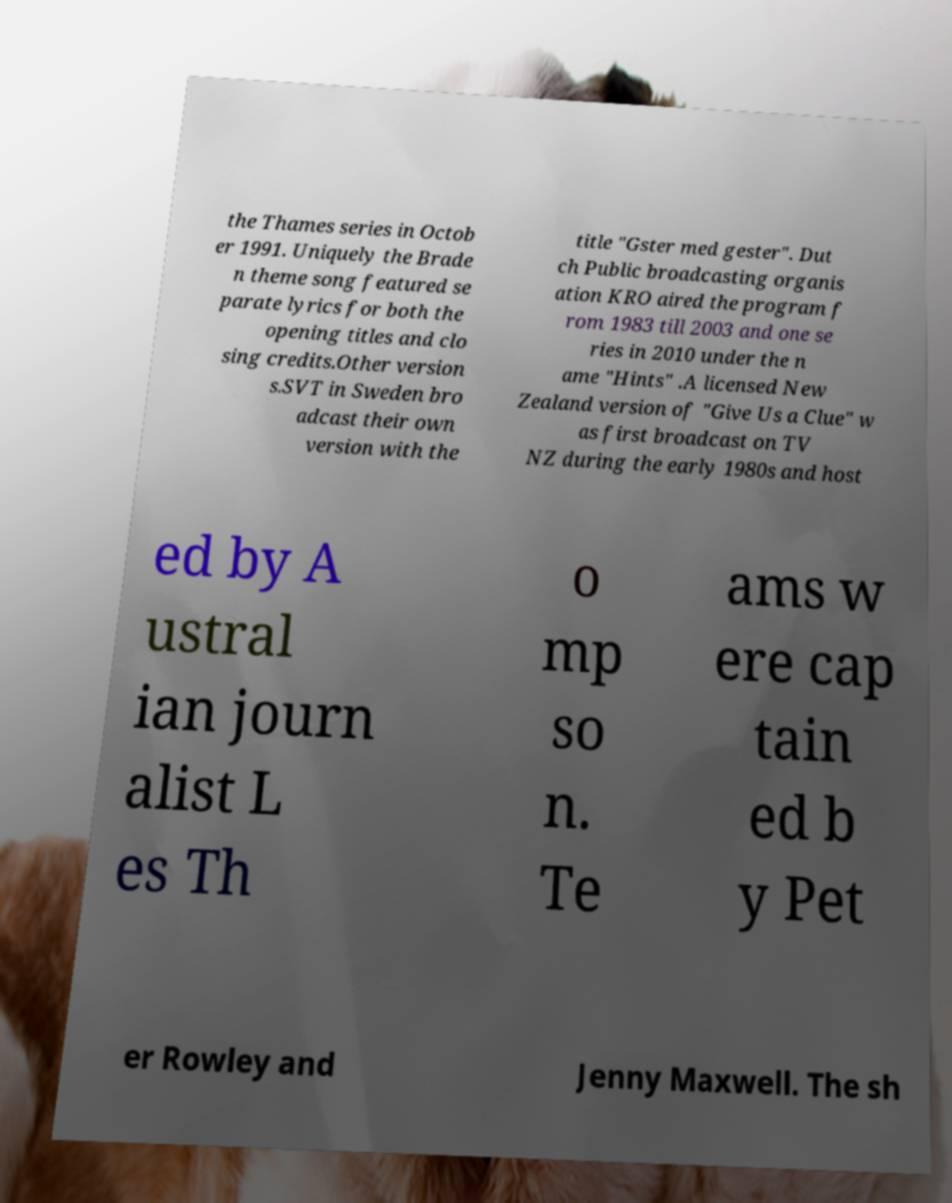What messages or text are displayed in this image? I need them in a readable, typed format. the Thames series in Octob er 1991. Uniquely the Brade n theme song featured se parate lyrics for both the opening titles and clo sing credits.Other version s.SVT in Sweden bro adcast their own version with the title "Gster med gester". Dut ch Public broadcasting organis ation KRO aired the program f rom 1983 till 2003 and one se ries in 2010 under the n ame "Hints" .A licensed New Zealand version of "Give Us a Clue" w as first broadcast on TV NZ during the early 1980s and host ed by A ustral ian journ alist L es Th o mp so n. Te ams w ere cap tain ed b y Pet er Rowley and Jenny Maxwell. The sh 